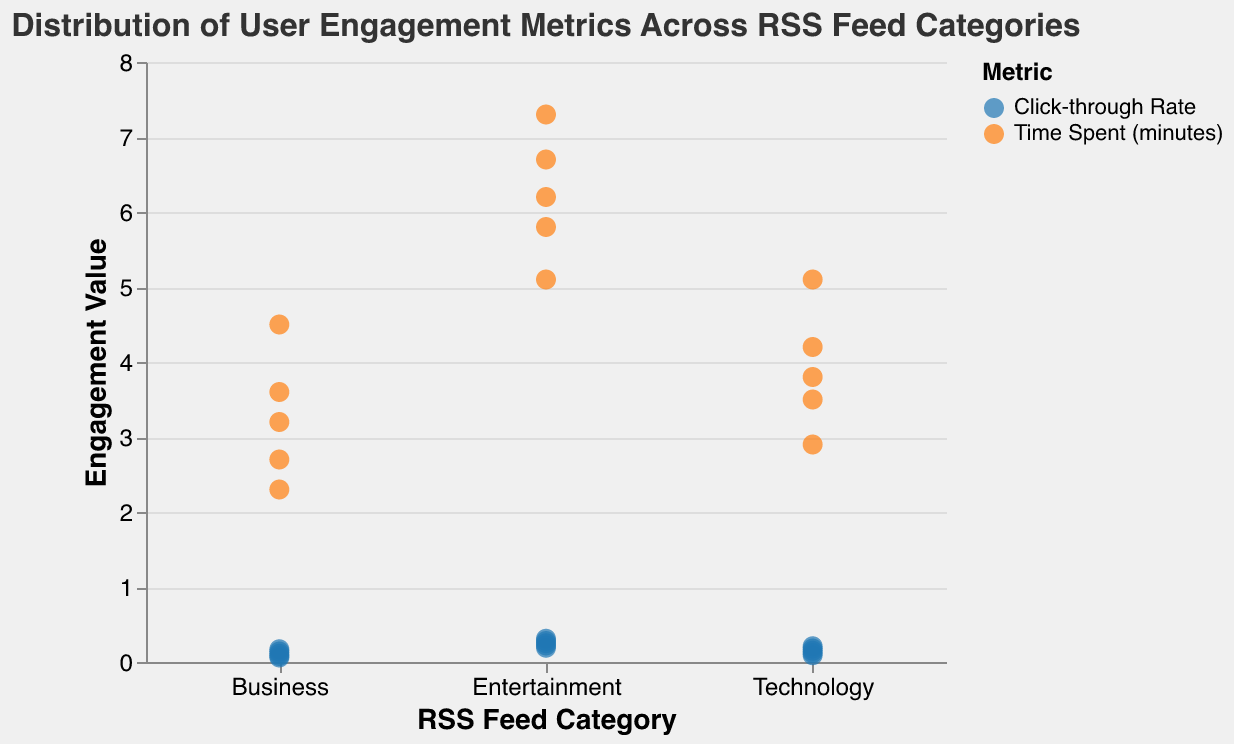What is the title of the plot? The title is displayed at the top of the plot. It provides a clear and concise description of what the plot represents. In this case, it is about the distribution of user engagement metrics across RSS feed categories.
Answer: Distribution of User Engagement Metrics Across RSS Feed Categories How many categories are displayed in the plot? By looking at the x-axis of the plot, we can see distinct labels for each category. There are three categories visible.
Answer: 3 What colors represent 'Click-through Rate' and 'Time Spent (minutes)'? The legend on the plot shows the corresponding color for each metric. 'Click-through Rate' is represented by blue, and 'Time Spent (minutes)' by orange.
Answer: Blue for 'Click-through Rate' and Orange for 'Time Spent (minutes)' Which category has the highest 'Click-through Rate' value? By observing the y-axis and the blue points (representing 'Click-through Rate'), we see that the highest value among them is for the 'Entertainment' category.
Answer: Entertainment Which metric has higher values on average in the 'Technology' category, 'Click-through Rate' or 'Time Spent (minutes)'? Calculate the average of 'Click-through Rate' and 'Time Spent (minutes)' for 'Technology'. 'Click-through Rate' values are {0.12, 0.18, 0.15, 0.21, 0.09}, averaging approximately 0.15. 'Time Spent (minutes)' values are {3.5, 4.2, 3.8, 5.1, 2.9}, averaging approximately 3.9. Thus, 'Time Spent (minutes)' has higher average values.
Answer: Time Spent (minutes) Compare the range of 'Click-through Rate' values between 'Business' and 'Entertainment'. The range is calculated as the difference between the maximum and minimum values for each category. For 'Business', the range is 0.17 - 0.06 = 0.11. For 'Entertainment', the range is 0.31 - 0.19 = 0.12.
Answer: Business: 0.11, Entertainment: 0.12 Which category has the widest spread in 'Time Spent (minutes)'? The spread is the difference between the maximum and minimum values. For 'Technology': 5.1 - 2.9 = 2.2. For 'Business': 4.5 - 2.3 = 2.2. For 'Entertainment': 7.3 - 5.1 = 2.2. Thus, all categories have the same spread in 'Time Spent (minutes)'.
Answer: All categories: 2.2 How does the median 'Click-through Rate' in 'Technology' compare to 'Business'? The median is the middle value when sorted in ascending order. For 'Technology', sorted values are {0.09, 0.12, 0.15, 0.18, 0.21}, median is 0.15. For 'Business', sorted values are {0.06, 0.08, 0.11, 0.14, 0.17}, median is 0.11. 'Technology' has a higher median.
Answer: Technology: 0.15, Business: 0.11 What is the maximum 'Time Spent (minutes)' for 'Entertainment' category? The highest 'Time Spent (minutes)' value for 'Entertainment' can be found by looking at the plot at the highest orange point for 'Entertainment'. This value is 7.3 minutes.
Answer: 7.3 